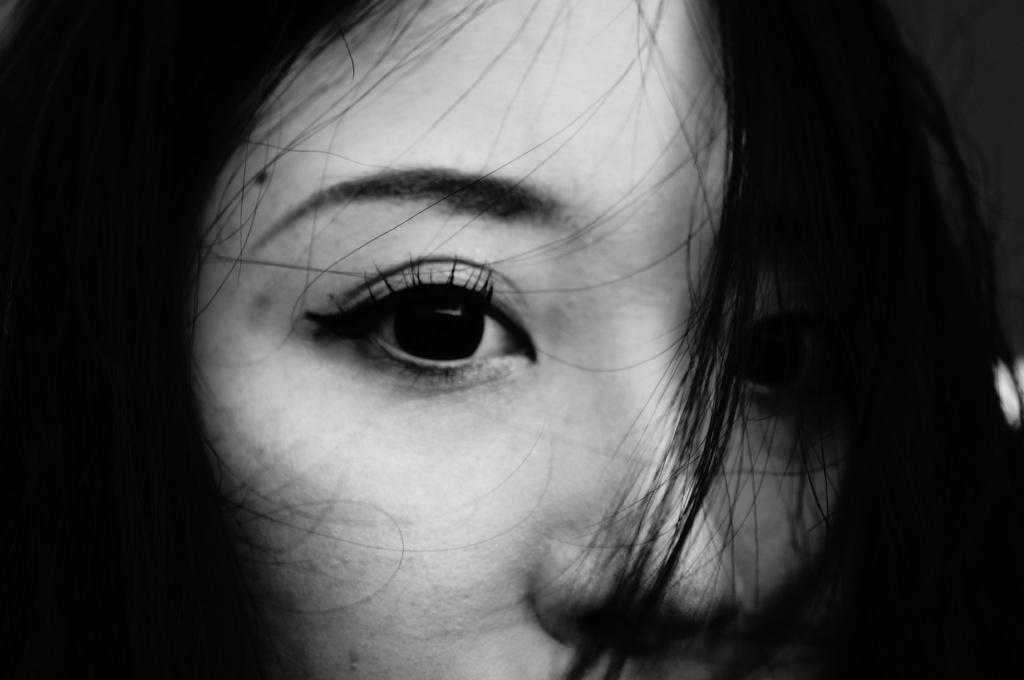What is the color scheme of the image? The image is black and white. Can you describe the main subject of the image? There is a person in the image. What type of orange is being held by the actor in the image? There is no orange or actor present in the image; it only features a person in a black and white setting. 